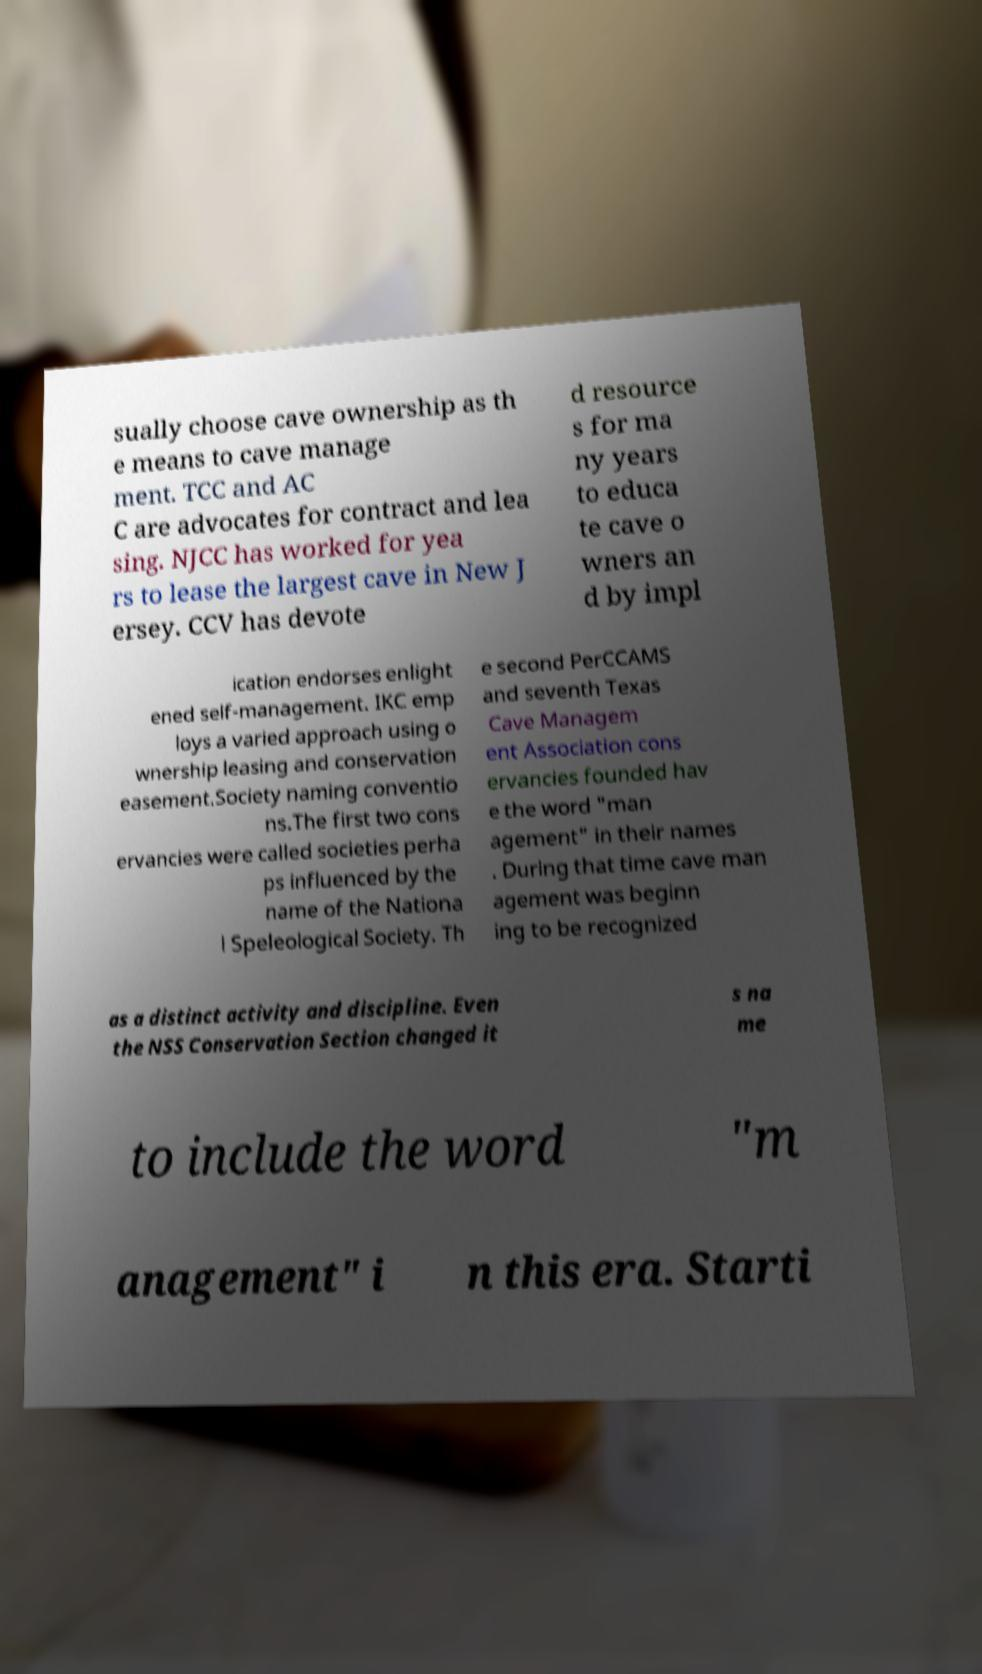Can you accurately transcribe the text from the provided image for me? sually choose cave ownership as th e means to cave manage ment. TCC and AC C are advocates for contract and lea sing. NJCC has worked for yea rs to lease the largest cave in New J ersey. CCV has devote d resource s for ma ny years to educa te cave o wners an d by impl ication endorses enlight ened self-management. IKC emp loys a varied approach using o wnership leasing and conservation easement.Society naming conventio ns.The first two cons ervancies were called societies perha ps influenced by the name of the Nationa l Speleological Society. Th e second PerCCAMS and seventh Texas Cave Managem ent Association cons ervancies founded hav e the word "man agement" in their names . During that time cave man agement was beginn ing to be recognized as a distinct activity and discipline. Even the NSS Conservation Section changed it s na me to include the word "m anagement" i n this era. Starti 